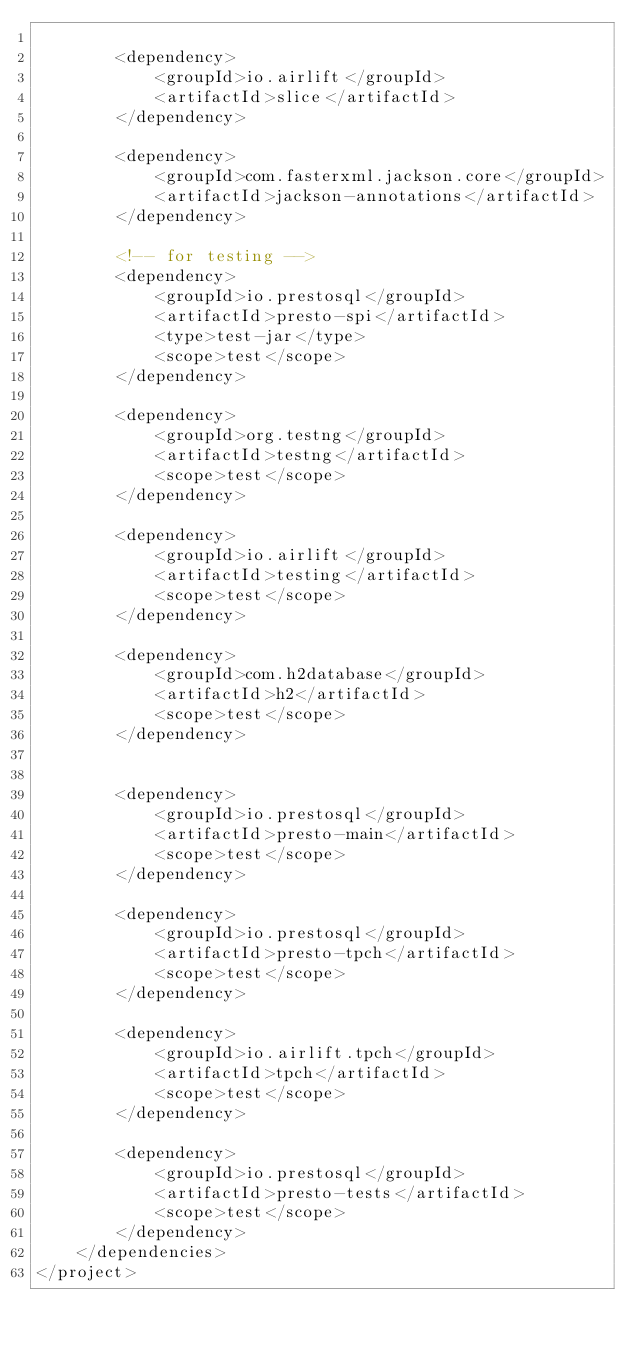Convert code to text. <code><loc_0><loc_0><loc_500><loc_500><_XML_>
        <dependency>
            <groupId>io.airlift</groupId>
            <artifactId>slice</artifactId>
        </dependency>

        <dependency>
            <groupId>com.fasterxml.jackson.core</groupId>
            <artifactId>jackson-annotations</artifactId>
        </dependency>

        <!-- for testing -->
        <dependency>
            <groupId>io.prestosql</groupId>
            <artifactId>presto-spi</artifactId>
            <type>test-jar</type>
            <scope>test</scope>
        </dependency>

        <dependency>
            <groupId>org.testng</groupId>
            <artifactId>testng</artifactId>
            <scope>test</scope>
        </dependency>

        <dependency>
            <groupId>io.airlift</groupId>
            <artifactId>testing</artifactId>
            <scope>test</scope>
        </dependency>

        <dependency>
            <groupId>com.h2database</groupId>
            <artifactId>h2</artifactId>
            <scope>test</scope>
        </dependency>


        <dependency>
            <groupId>io.prestosql</groupId>
            <artifactId>presto-main</artifactId>
            <scope>test</scope>
        </dependency>

        <dependency>
            <groupId>io.prestosql</groupId>
            <artifactId>presto-tpch</artifactId>
            <scope>test</scope>
        </dependency>

        <dependency>
            <groupId>io.airlift.tpch</groupId>
            <artifactId>tpch</artifactId>
            <scope>test</scope>
        </dependency>

        <dependency>
            <groupId>io.prestosql</groupId>
            <artifactId>presto-tests</artifactId>
            <scope>test</scope>
        </dependency>
    </dependencies>
</project>
</code> 